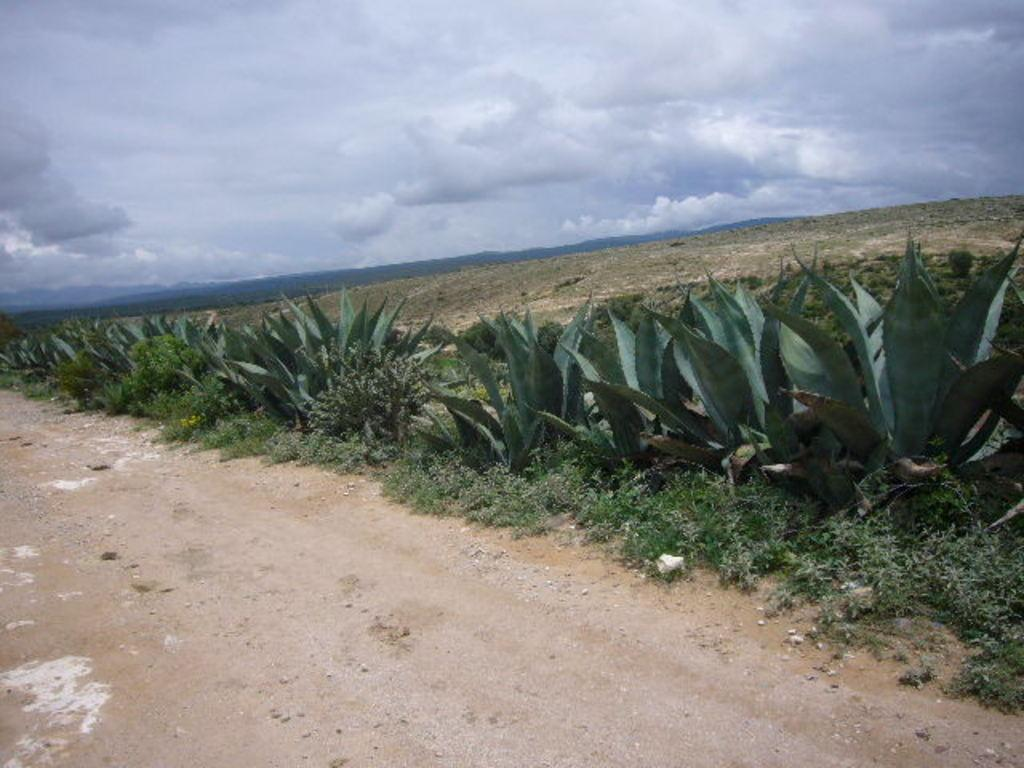What type of vegetation can be seen in the image? There are plants and grass in the image. What is located at the bottom of the image? There is a walkway at the bottom of the image. What is visible in the background of the image? The sky is visible in the background of the image. How would you describe the sky in the image? The sky appears to be cloudy in the image. What type of scent can be detected in the lunchroom in the image? There is no lunchroom present in the image, so it is not possible to determine what scent might be detected. 